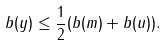Convert formula to latex. <formula><loc_0><loc_0><loc_500><loc_500>b ( y ) \leq \frac { 1 } { 2 } ( b ( m ) + b ( u ) ) .</formula> 